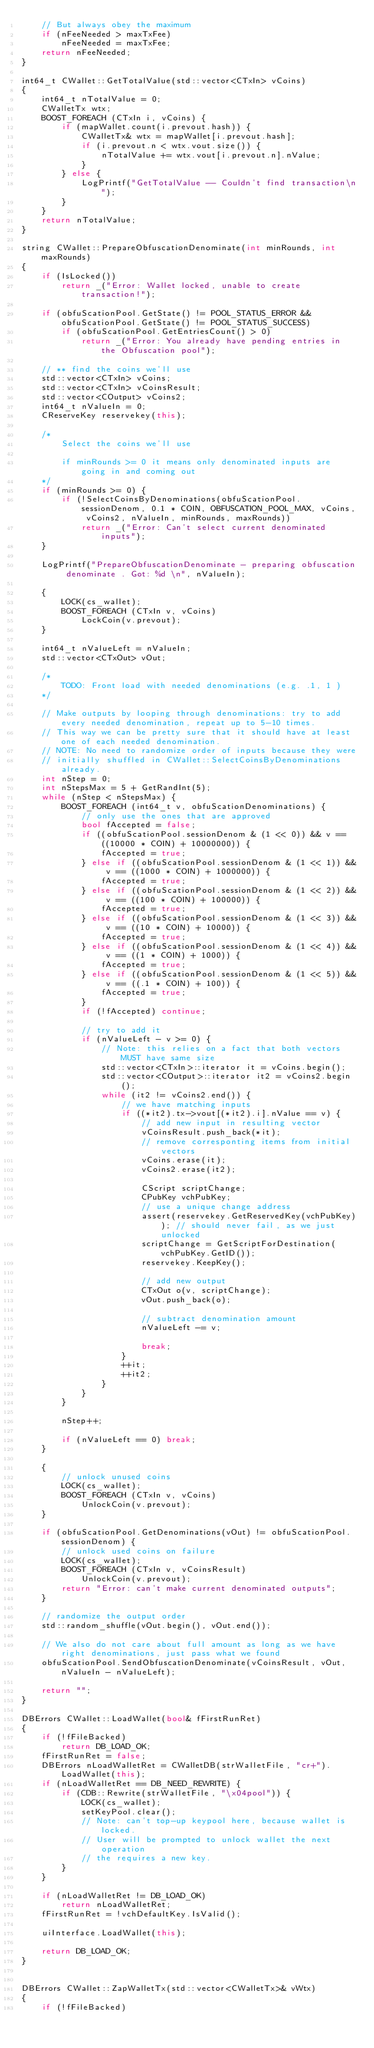Convert code to text. <code><loc_0><loc_0><loc_500><loc_500><_C++_>    // But always obey the maximum
    if (nFeeNeeded > maxTxFee)
        nFeeNeeded = maxTxFee;
    return nFeeNeeded;
}

int64_t CWallet::GetTotalValue(std::vector<CTxIn> vCoins)
{
    int64_t nTotalValue = 0;
    CWalletTx wtx;
    BOOST_FOREACH (CTxIn i, vCoins) {
        if (mapWallet.count(i.prevout.hash)) {
            CWalletTx& wtx = mapWallet[i.prevout.hash];
            if (i.prevout.n < wtx.vout.size()) {
                nTotalValue += wtx.vout[i.prevout.n].nValue;
            }
        } else {
            LogPrintf("GetTotalValue -- Couldn't find transaction\n");
        }
    }
    return nTotalValue;
}

string CWallet::PrepareObfuscationDenominate(int minRounds, int maxRounds)
{
    if (IsLocked())
        return _("Error: Wallet locked, unable to create transaction!");

    if (obfuScationPool.GetState() != POOL_STATUS_ERROR && obfuScationPool.GetState() != POOL_STATUS_SUCCESS)
        if (obfuScationPool.GetEntriesCount() > 0)
            return _("Error: You already have pending entries in the Obfuscation pool");

    // ** find the coins we'll use
    std::vector<CTxIn> vCoins;
    std::vector<CTxIn> vCoinsResult;
    std::vector<COutput> vCoins2;
    int64_t nValueIn = 0;
    CReserveKey reservekey(this);

    /*
        Select the coins we'll use

        if minRounds >= 0 it means only denominated inputs are going in and coming out
    */
    if (minRounds >= 0) {
        if (!SelectCoinsByDenominations(obfuScationPool.sessionDenom, 0.1 * COIN, OBFUSCATION_POOL_MAX, vCoins, vCoins2, nValueIn, minRounds, maxRounds))
            return _("Error: Can't select current denominated inputs");
    }

    LogPrintf("PrepareObfuscationDenominate - preparing obfuscation denominate . Got: %d \n", nValueIn);

    {
        LOCK(cs_wallet);
        BOOST_FOREACH (CTxIn v, vCoins)
            LockCoin(v.prevout);
    }

    int64_t nValueLeft = nValueIn;
    std::vector<CTxOut> vOut;

    /*
        TODO: Front load with needed denominations (e.g. .1, 1 )
    */

    // Make outputs by looping through denominations: try to add every needed denomination, repeat up to 5-10 times.
    // This way we can be pretty sure that it should have at least one of each needed denomination.
    // NOTE: No need to randomize order of inputs because they were
    // initially shuffled in CWallet::SelectCoinsByDenominations already.
    int nStep = 0;
    int nStepsMax = 5 + GetRandInt(5);
    while (nStep < nStepsMax) {
        BOOST_FOREACH (int64_t v, obfuScationDenominations) {
            // only use the ones that are approved
            bool fAccepted = false;
            if ((obfuScationPool.sessionDenom & (1 << 0)) && v == ((10000 * COIN) + 10000000)) {
                fAccepted = true;
            } else if ((obfuScationPool.sessionDenom & (1 << 1)) && v == ((1000 * COIN) + 1000000)) {
                fAccepted = true;
            } else if ((obfuScationPool.sessionDenom & (1 << 2)) && v == ((100 * COIN) + 100000)) {
                fAccepted = true;
            } else if ((obfuScationPool.sessionDenom & (1 << 3)) && v == ((10 * COIN) + 10000)) {
                fAccepted = true;
            } else if ((obfuScationPool.sessionDenom & (1 << 4)) && v == ((1 * COIN) + 1000)) {
                fAccepted = true;
            } else if ((obfuScationPool.sessionDenom & (1 << 5)) && v == ((.1 * COIN) + 100)) {
                fAccepted = true;
            }
            if (!fAccepted) continue;

            // try to add it
            if (nValueLeft - v >= 0) {
                // Note: this relies on a fact that both vectors MUST have same size
                std::vector<CTxIn>::iterator it = vCoins.begin();
                std::vector<COutput>::iterator it2 = vCoins2.begin();
                while (it2 != vCoins2.end()) {
                    // we have matching inputs
                    if ((*it2).tx->vout[(*it2).i].nValue == v) {
                        // add new input in resulting vector
                        vCoinsResult.push_back(*it);
                        // remove corresponting items from initial vectors
                        vCoins.erase(it);
                        vCoins2.erase(it2);

                        CScript scriptChange;
                        CPubKey vchPubKey;
                        // use a unique change address
                        assert(reservekey.GetReservedKey(vchPubKey)); // should never fail, as we just unlocked
                        scriptChange = GetScriptForDestination(vchPubKey.GetID());
                        reservekey.KeepKey();

                        // add new output
                        CTxOut o(v, scriptChange);
                        vOut.push_back(o);

                        // subtract denomination amount
                        nValueLeft -= v;

                        break;
                    }
                    ++it;
                    ++it2;
                }
            }
        }

        nStep++;

        if (nValueLeft == 0) break;
    }

    {
        // unlock unused coins
        LOCK(cs_wallet);
        BOOST_FOREACH (CTxIn v, vCoins)
            UnlockCoin(v.prevout);
    }

    if (obfuScationPool.GetDenominations(vOut) != obfuScationPool.sessionDenom) {
        // unlock used coins on failure
        LOCK(cs_wallet);
        BOOST_FOREACH (CTxIn v, vCoinsResult)
            UnlockCoin(v.prevout);
        return "Error: can't make current denominated outputs";
    }

    // randomize the output order
    std::random_shuffle(vOut.begin(), vOut.end());

    // We also do not care about full amount as long as we have right denominations, just pass what we found
    obfuScationPool.SendObfuscationDenominate(vCoinsResult, vOut, nValueIn - nValueLeft);

    return "";
}

DBErrors CWallet::LoadWallet(bool& fFirstRunRet)
{
    if (!fFileBacked)
        return DB_LOAD_OK;
    fFirstRunRet = false;
    DBErrors nLoadWalletRet = CWalletDB(strWalletFile, "cr+").LoadWallet(this);
    if (nLoadWalletRet == DB_NEED_REWRITE) {
        if (CDB::Rewrite(strWalletFile, "\x04pool")) {
            LOCK(cs_wallet);
            setKeyPool.clear();
            // Note: can't top-up keypool here, because wallet is locked.
            // User will be prompted to unlock wallet the next operation
            // the requires a new key.
        }
    }

    if (nLoadWalletRet != DB_LOAD_OK)
        return nLoadWalletRet;
    fFirstRunRet = !vchDefaultKey.IsValid();

    uiInterface.LoadWallet(this);

    return DB_LOAD_OK;
}


DBErrors CWallet::ZapWalletTx(std::vector<CWalletTx>& vWtx)
{
    if (!fFileBacked)</code> 